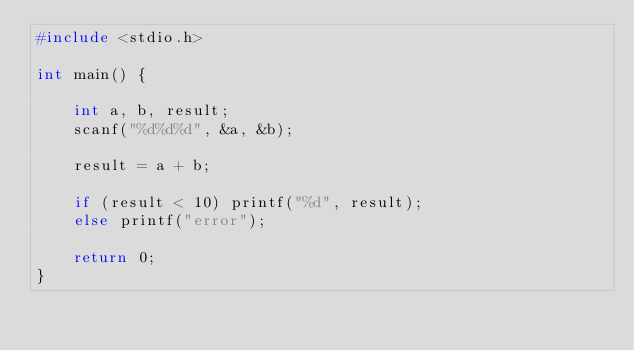Convert code to text. <code><loc_0><loc_0><loc_500><loc_500><_C_>#include <stdio.h>

int main() {
	
	int a, b, result;
	scanf("%d%d%d", &a, &b);
	
	result = a + b;
	
	if (result < 10) printf("%d", result);
	else printf("error");
	
	return 0;
}</code> 